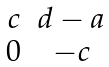Convert formula to latex. <formula><loc_0><loc_0><loc_500><loc_500>\begin{matrix} c & d - a \\ 0 & - c \end{matrix}</formula> 